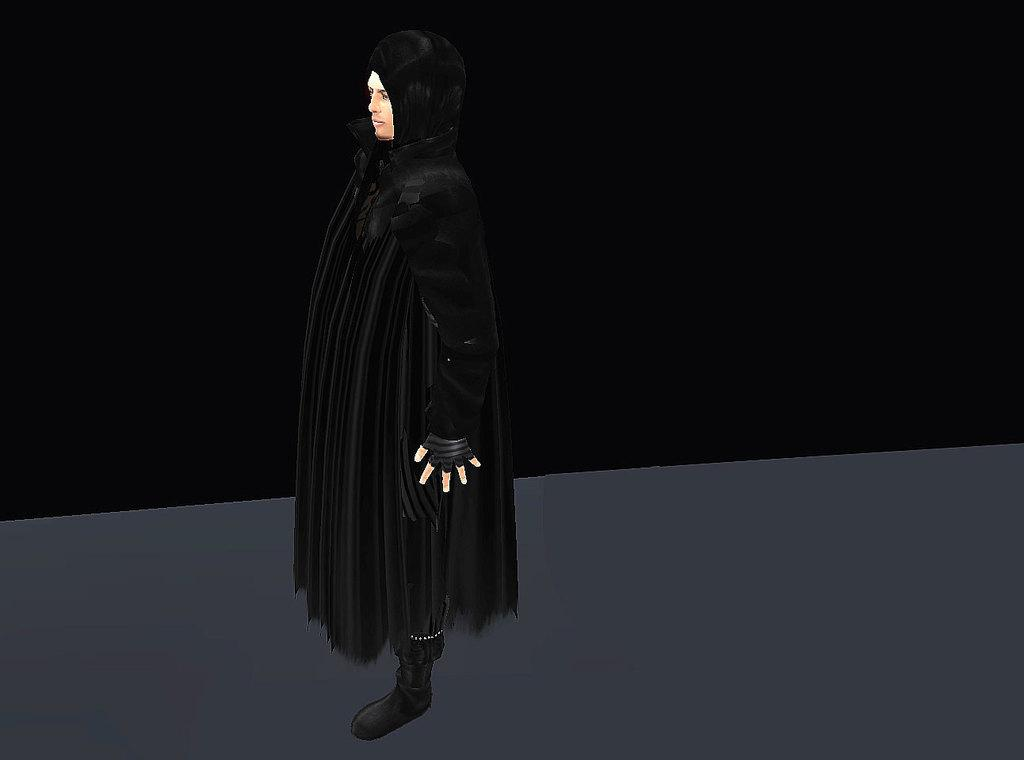Who is in the image? There is a person in the image. What is the person wearing? The person is wearing a black dress. How is the person described? The person is described as stunning. What colors are present in the background of the image? There is a black background and a grey background at the bottom of the image. Where is the jail located in the image? There is no jail present in the image. What type of sock is the person wearing in the image? The person in the image is not wearing any socks. Is the person wearing a crown in the image? There is no crown visible in the image. 